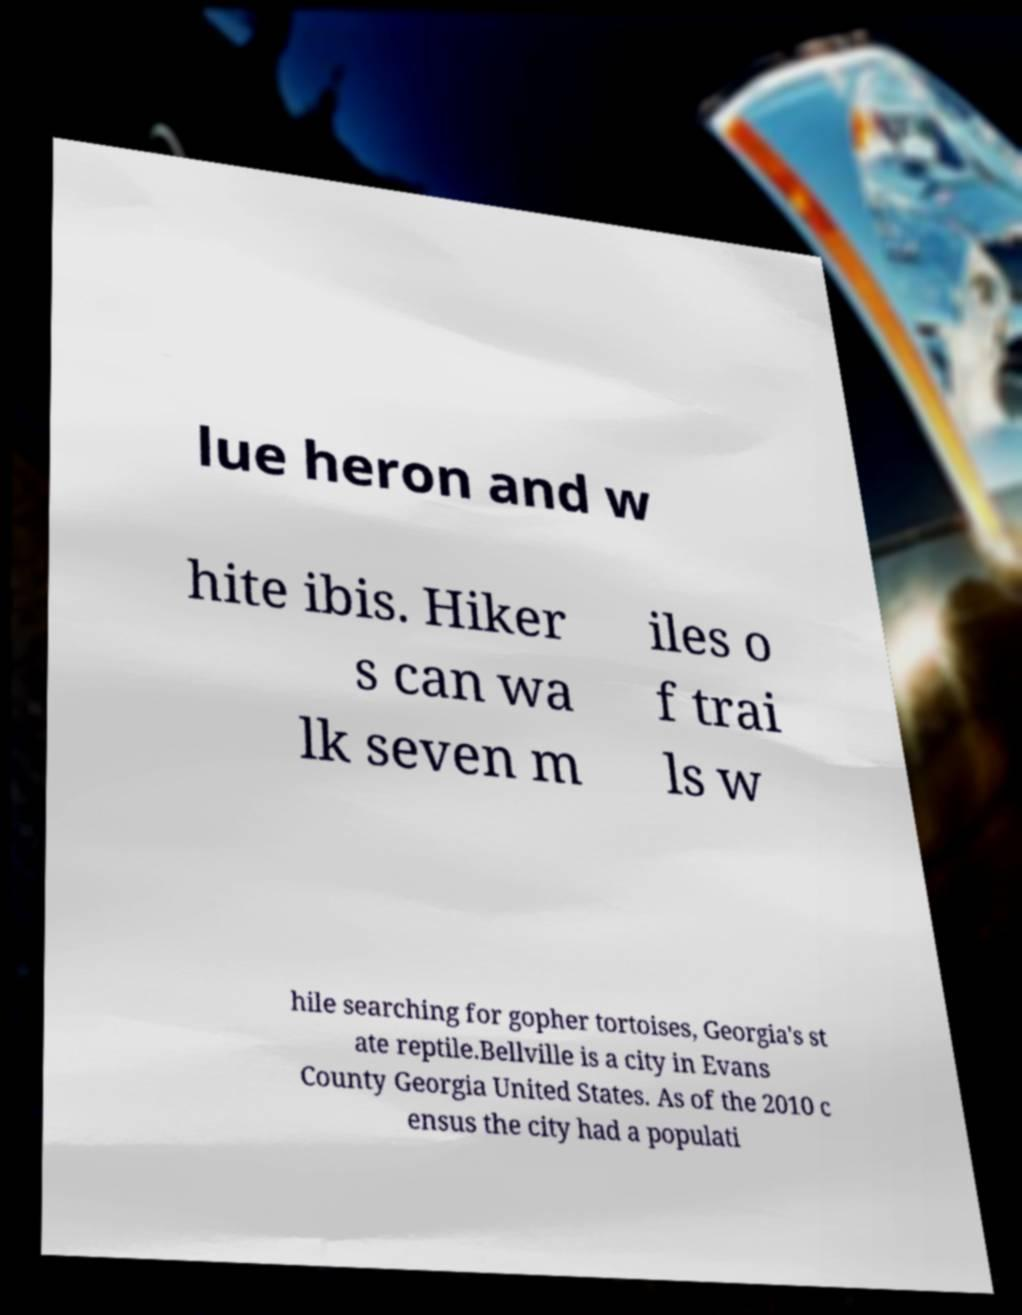Can you accurately transcribe the text from the provided image for me? lue heron and w hite ibis. Hiker s can wa lk seven m iles o f trai ls w hile searching for gopher tortoises, Georgia's st ate reptile.Bellville is a city in Evans County Georgia United States. As of the 2010 c ensus the city had a populati 